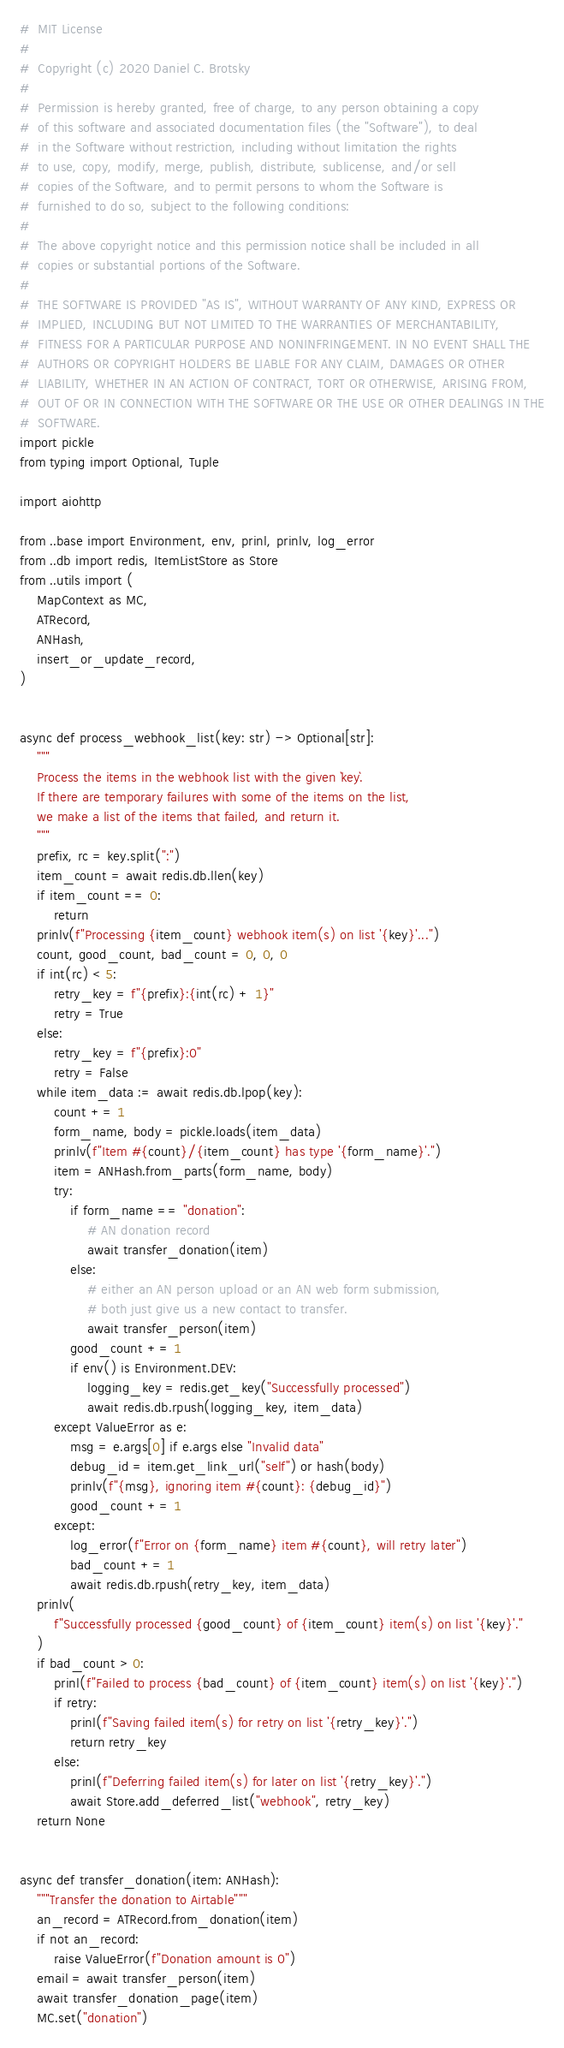<code> <loc_0><loc_0><loc_500><loc_500><_Python_>#  MIT License
#
#  Copyright (c) 2020 Daniel C. Brotsky
#
#  Permission is hereby granted, free of charge, to any person obtaining a copy
#  of this software and associated documentation files (the "Software"), to deal
#  in the Software without restriction, including without limitation the rights
#  to use, copy, modify, merge, publish, distribute, sublicense, and/or sell
#  copies of the Software, and to permit persons to whom the Software is
#  furnished to do so, subject to the following conditions:
#
#  The above copyright notice and this permission notice shall be included in all
#  copies or substantial portions of the Software.
#
#  THE SOFTWARE IS PROVIDED "AS IS", WITHOUT WARRANTY OF ANY KIND, EXPRESS OR
#  IMPLIED, INCLUDING BUT NOT LIMITED TO THE WARRANTIES OF MERCHANTABILITY,
#  FITNESS FOR A PARTICULAR PURPOSE AND NONINFRINGEMENT. IN NO EVENT SHALL THE
#  AUTHORS OR COPYRIGHT HOLDERS BE LIABLE FOR ANY CLAIM, DAMAGES OR OTHER
#  LIABILITY, WHETHER IN AN ACTION OF CONTRACT, TORT OR OTHERWISE, ARISING FROM,
#  OUT OF OR IN CONNECTION WITH THE SOFTWARE OR THE USE OR OTHER DEALINGS IN THE
#  SOFTWARE.
import pickle
from typing import Optional, Tuple

import aiohttp

from ..base import Environment, env, prinl, prinlv, log_error
from ..db import redis, ItemListStore as Store
from ..utils import (
    MapContext as MC,
    ATRecord,
    ANHash,
    insert_or_update_record,
)


async def process_webhook_list(key: str) -> Optional[str]:
    """
    Process the items in the webhook list with the given `key`.
    If there are temporary failures with some of the items on the list,
    we make a list of the items that failed, and return it.
    """
    prefix, rc = key.split(":")
    item_count = await redis.db.llen(key)
    if item_count == 0:
        return
    prinlv(f"Processing {item_count} webhook item(s) on list '{key}'...")
    count, good_count, bad_count = 0, 0, 0
    if int(rc) < 5:
        retry_key = f"{prefix}:{int(rc) + 1}"
        retry = True
    else:
        retry_key = f"{prefix}:0"
        retry = False
    while item_data := await redis.db.lpop(key):
        count += 1
        form_name, body = pickle.loads(item_data)
        prinlv(f"Item #{count}/{item_count} has type '{form_name}'.")
        item = ANHash.from_parts(form_name, body)
        try:
            if form_name == "donation":
                # AN donation record
                await transfer_donation(item)
            else:
                # either an AN person upload or an AN web form submission,
                # both just give us a new contact to transfer.
                await transfer_person(item)
            good_count += 1
            if env() is Environment.DEV:
                logging_key = redis.get_key("Successfully processed")
                await redis.db.rpush(logging_key, item_data)
        except ValueError as e:
            msg = e.args[0] if e.args else "Invalid data"
            debug_id = item.get_link_url("self") or hash(body)
            prinlv(f"{msg}, ignoring item #{count}: {debug_id}")
            good_count += 1
        except:
            log_error(f"Error on {form_name} item #{count}, will retry later")
            bad_count += 1
            await redis.db.rpush(retry_key, item_data)
    prinlv(
        f"Successfully processed {good_count} of {item_count} item(s) on list '{key}'."
    )
    if bad_count > 0:
        prinl(f"Failed to process {bad_count} of {item_count} item(s) on list '{key}'.")
        if retry:
            prinl(f"Saving failed item(s) for retry on list '{retry_key}'.")
            return retry_key
        else:
            prinl(f"Deferring failed item(s) for later on list '{retry_key}'.")
            await Store.add_deferred_list("webhook", retry_key)
    return None


async def transfer_donation(item: ANHash):
    """Transfer the donation to Airtable"""
    an_record = ATRecord.from_donation(item)
    if not an_record:
        raise ValueError(f"Donation amount is 0")
    email = await transfer_person(item)
    await transfer_donation_page(item)
    MC.set("donation")</code> 